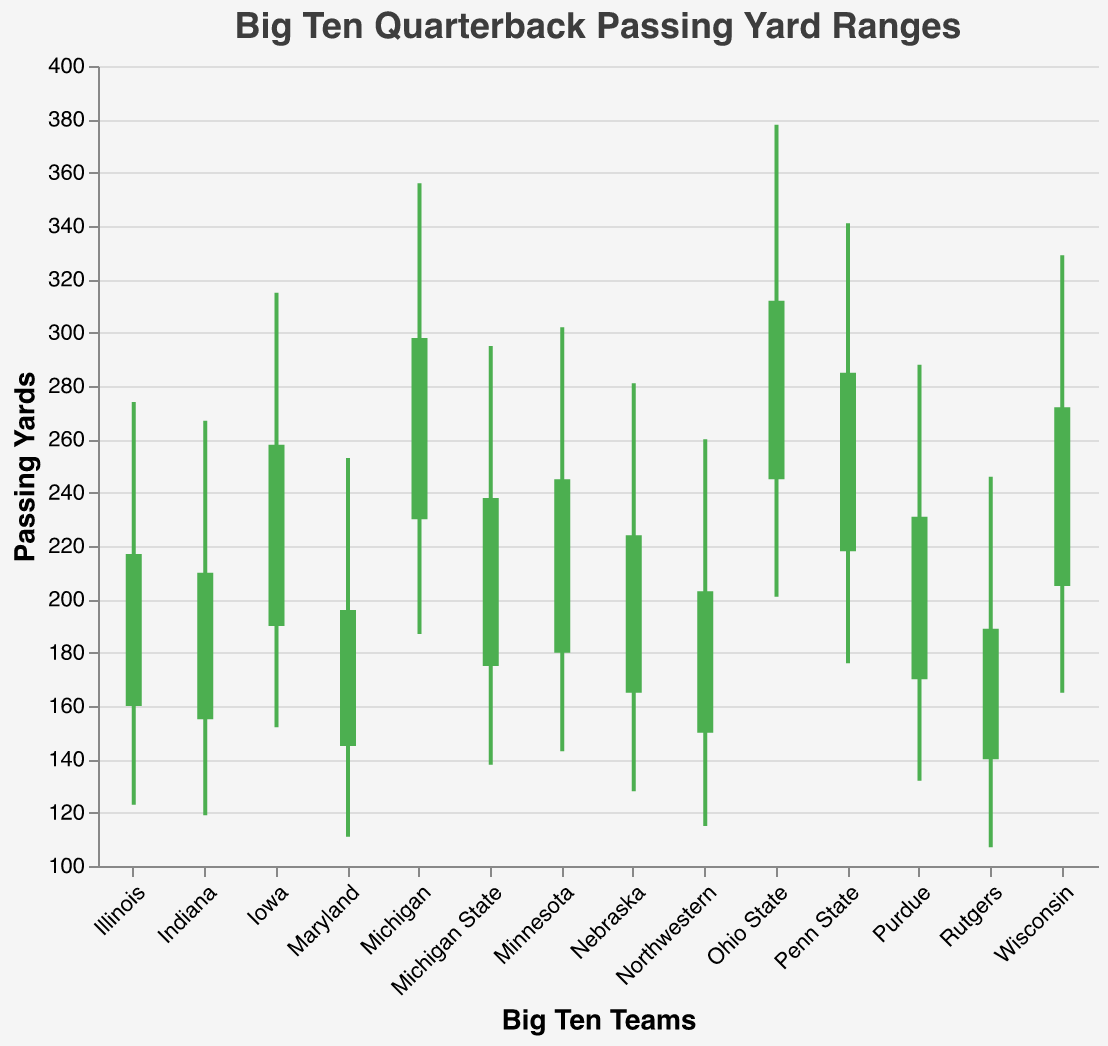How many Big Ten teams are depicted in the figure? Count the number of teams listed on the x-axis.
Answer: 14 What is the passing yard range for Ohio State? The range is defined by the 'Low' and 'High' values for Ohio State. According to the data, these values are 201 and 378 respectively.
Answer: 201 to 378 Which team has the lowest minimum passing yard value? Compare the 'Low' values for all teams and identify the smallest one. Rutgers has the lowest 'Low' value at 107.
Answer: Rutgers Which team shows the greatest difference between their 'High' and 'Low' passing yard values? Calculate the difference between 'High' and 'Low' for each team. Ohio State has the highest difference at 378 - 201 = 177.
Answer: Ohio State Which team shows a decrease in passing yards from Open to Close? Identify the teams where the 'Open' value is greater than the 'Close' value. None of the teams listed show a decrease from Open to Close.
Answer: None How does Michigan compare to Penn State in terms of maximum passing yards? Compare the 'High' values for Michigan and Penn State. Michigan's 'High' value is 356, and Penn State's 'High' value is 341.
Answer: Michigan has higher maximum passing yards What is the average 'Low' value across all teams? Sum all the 'Low' values and divide by the number of teams (14). The sum of 'Low' values is 2185, so the average is 2185 / 14 ≈ 156.07.
Answer: 156.07 Which team has the smallest difference between their 'Open' and 'Close' passing yards? Calculate the difference between 'Open' and 'Close' for each team. Maryland has the smallest difference with an 'Open' of 145 and 'Close' of 196, so the difference is 196 - 145 = 51.
Answer: Maryland What are the colors used to indicate whether teams have increased or decreased their passing yards? The rule is that green (#4CAF50) is used if 'Open' < 'Close' and red (#F44336) if 'Open' > 'Close'.
Answer: Green and Red What is the combined passing yard range of the top three teams with the highest 'High' values? Identify the top three 'High' values (Ohio State - 378, Michigan - 356, Penn State - 341) and sum them. The combined range is 378 + 356 + 341 = 1075.
Answer: 1075 